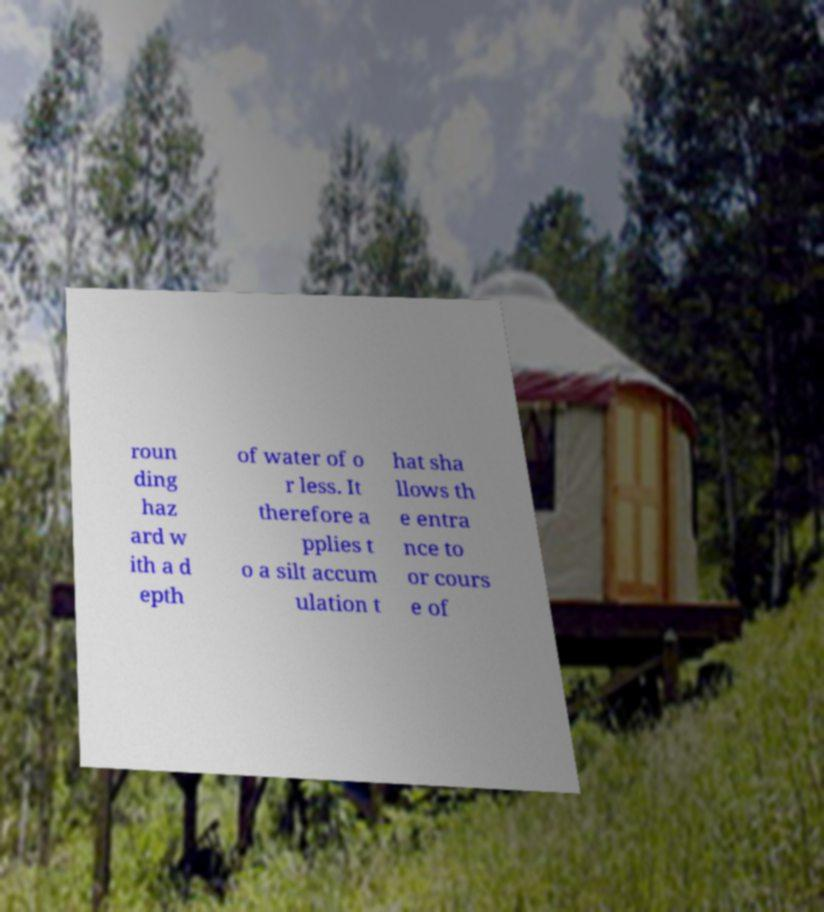Can you read and provide the text displayed in the image?This photo seems to have some interesting text. Can you extract and type it out for me? roun ding haz ard w ith a d epth of water of o r less. It therefore a pplies t o a silt accum ulation t hat sha llows th e entra nce to or cours e of 